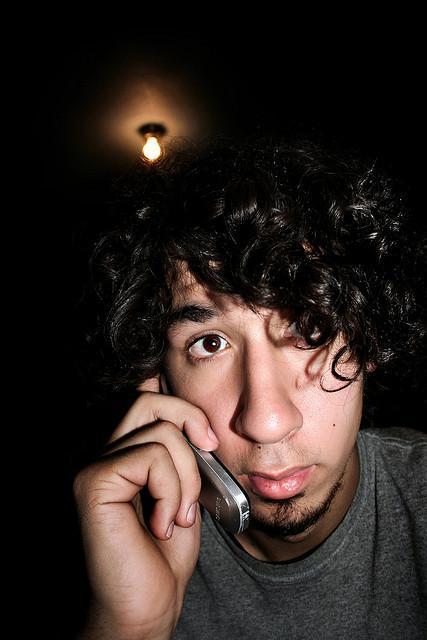How many people in this image are dragging a suitcase behind them?
Give a very brief answer. 0. 